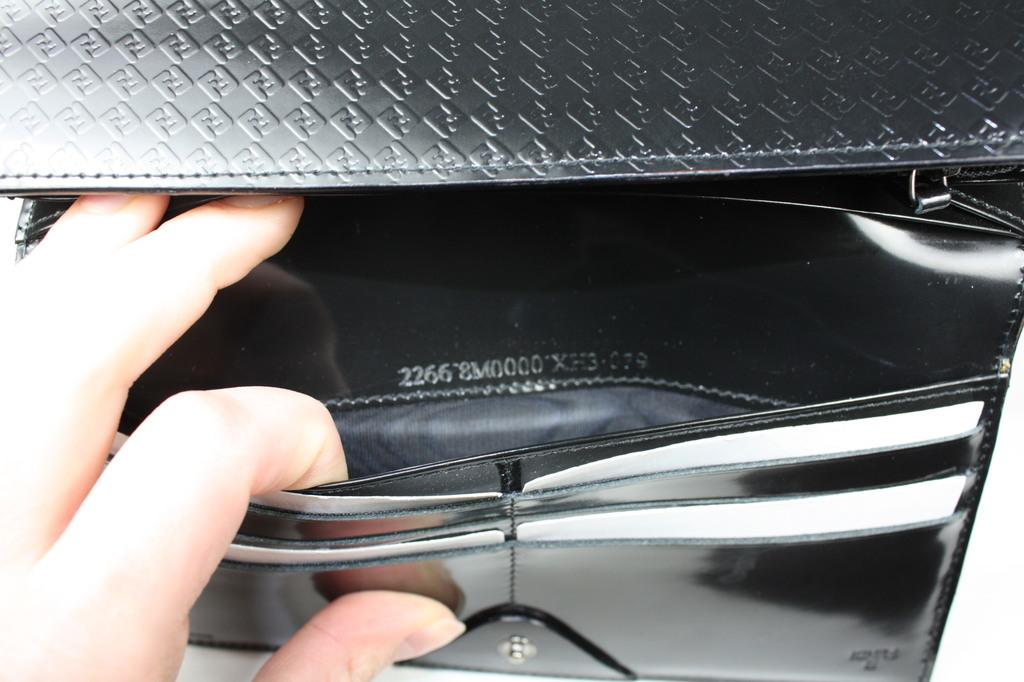What can be seen in the image related to a person's hand? There is a person's hand in the image. What is the hand holding in the image? The hand is holding a black color wallet. Is the person wearing a ring on their hand in the image? There is no indication of a ring on the person's hand in the image. What angle is the hand holding the wallet at in the image? The angle of the hand holding the wallet cannot be determined from the image, as it only shows the hand and wallet without any perspective or depth information. 